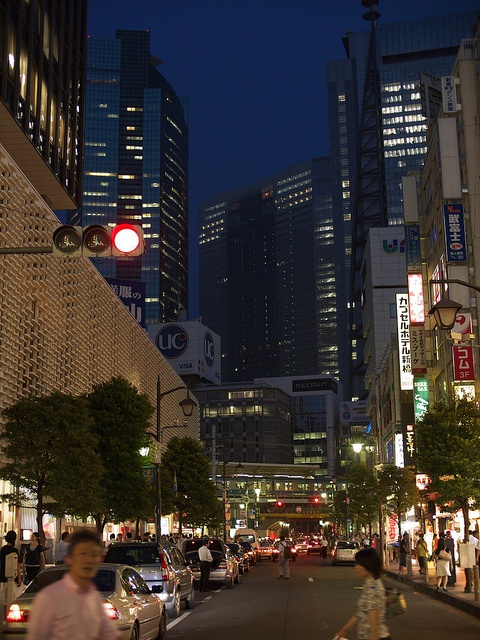Describe the objects in this image and their specific colors. I can see people in black, brown, and maroon tones, car in black, maroon, and gray tones, car in black, maroon, and gray tones, people in black, maroon, and olive tones, and traffic light in black, gray, white, and maroon tones in this image. 